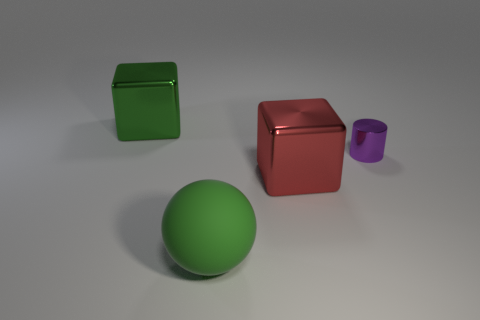Can you tell me what colors the objects in this image have? Certainly! In this image, there is a green cube, a red cube, a purple cylinder, and a green sphere. 